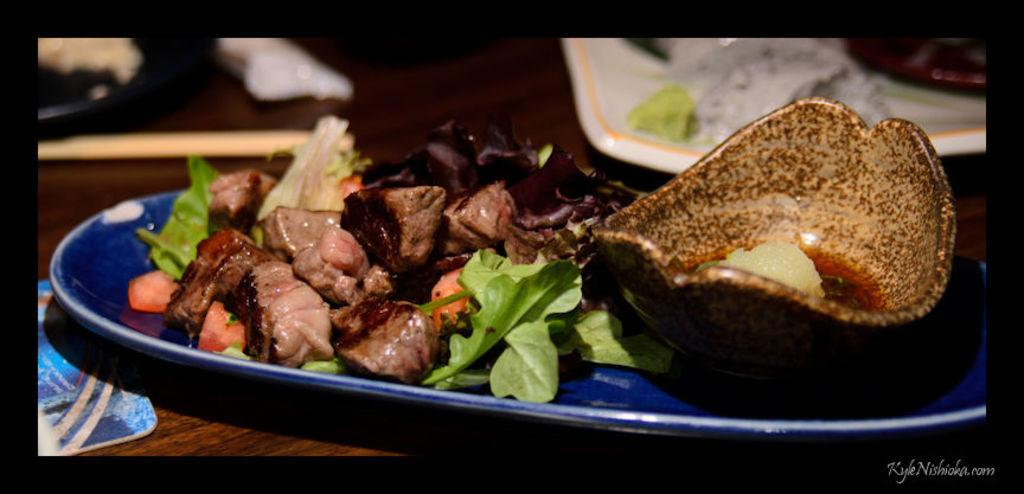What is the main piece of furniture in the image? There is a table in the image. What is placed on the table? There is a plate with food items on the table. Are there any utensils visible near the plate? There may be chopsticks beside the plate. Are there any other plates with food items on the table? Yes, there is another plate with food items on the table. Can you hear the ants talking to each other in the image? There are no ants present in the image, so it is not possible to hear them talking. 